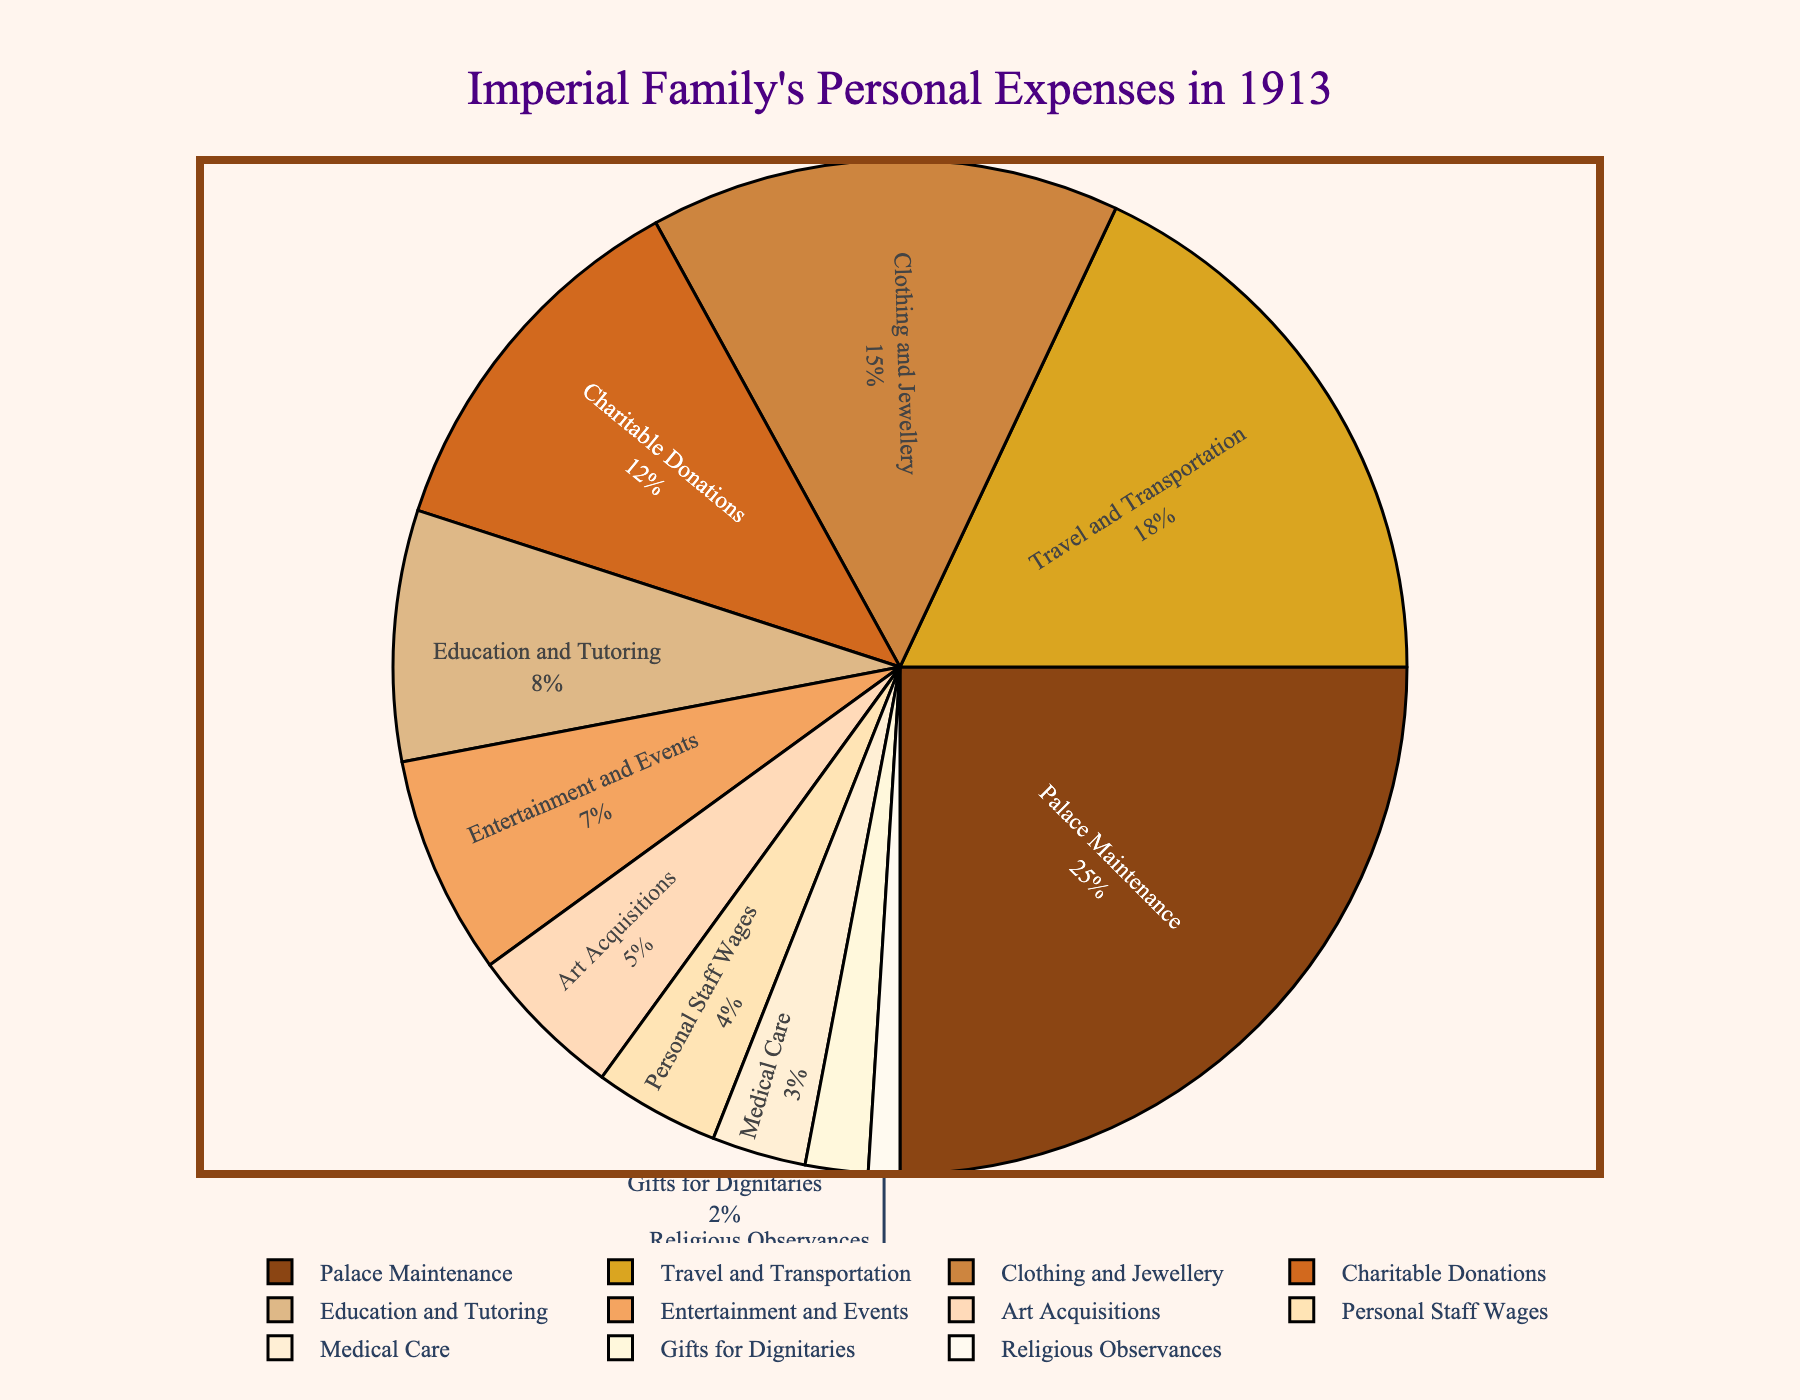What was the percentage of expenses for Charitable Donations and Education and Tutoring combined? To find the combined percentage, we simply add the percentages for Charitable Donations (12%) and Education and Tutoring (8%). 12 + 8 = 20
Answer: 20 Which expense category received a higher allocation: Clothing and Jewellery or Travel and Transportation? By comparing the percentages for each category, we see that Travel and Transportation was allocated 18% while Clothing and Jewellery was allocated 15%. 18% is higher than 15%.
Answer: Travel and Transportation What is the difference in percentage between the expenses for Palace Maintenance and Entertainment and Events? To find the difference, subtract the percentage for Entertainment and Events (7%) from the percentage for Palace Maintenance (25%). 25 - 7 = 18
Answer: 18 If Palace Maintenance, Travel and Transportation, and Clothing and Jewellery constitute over half of the total expenses, what’s the percentage for this group? Adding the percentages for Palace Maintenance (25%), Travel and Transportation (18%), and Clothing and Jewellery (15%) gives us 25 + 18 + 15 = 58. Since 58% is over half, this confirms the assumption.
Answer: 58 Is the expense for Medical Care higher than that for Gifts for Dignitaries? Comparing the percentages, Medical Care has 3% while Gifts for Dignitaries has 2%. Since 3% is greater than 2%, Medical Care has a higher allocation.
Answer: Yes Which category has the lowest allocation, and what is its percentage? By looking at the categories and their percentages, Religious Observances has the lowest allocation at 1%.
Answer: Religious Observances, 1 In terms of expense allocation, what relationship do you observe between Art Acquisitions and Education and Tutoring? Art Acquisitions is allocated 5%, while Education and Tutoring is allocated 8%. Therefore, Education and Tutoring has a higher allocation than Art Acquisitions.
Answer: Education and Tutoring > Art Acquisitions 